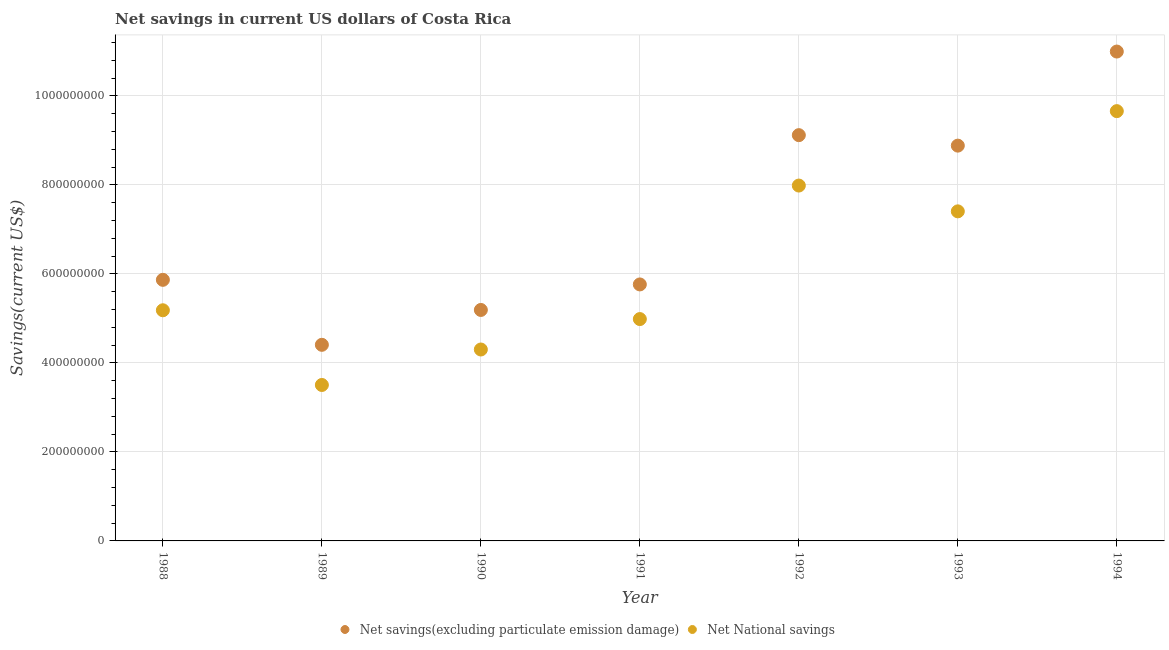What is the net savings(excluding particulate emission damage) in 1990?
Your answer should be very brief. 5.19e+08. Across all years, what is the maximum net savings(excluding particulate emission damage)?
Your answer should be compact. 1.10e+09. Across all years, what is the minimum net savings(excluding particulate emission damage)?
Give a very brief answer. 4.41e+08. In which year was the net national savings maximum?
Your answer should be compact. 1994. In which year was the net national savings minimum?
Your answer should be compact. 1989. What is the total net savings(excluding particulate emission damage) in the graph?
Your response must be concise. 5.02e+09. What is the difference between the net national savings in 1989 and that in 1994?
Provide a short and direct response. -6.15e+08. What is the difference between the net national savings in 1990 and the net savings(excluding particulate emission damage) in 1991?
Your answer should be very brief. -1.46e+08. What is the average net national savings per year?
Ensure brevity in your answer.  6.14e+08. In the year 1991, what is the difference between the net national savings and net savings(excluding particulate emission damage)?
Keep it short and to the point. -7.78e+07. In how many years, is the net national savings greater than 480000000 US$?
Provide a succinct answer. 5. What is the ratio of the net national savings in 1988 to that in 1991?
Make the answer very short. 1.04. Is the difference between the net national savings in 1990 and 1993 greater than the difference between the net savings(excluding particulate emission damage) in 1990 and 1993?
Your answer should be compact. Yes. What is the difference between the highest and the second highest net savings(excluding particulate emission damage)?
Your response must be concise. 1.88e+08. What is the difference between the highest and the lowest net savings(excluding particulate emission damage)?
Your response must be concise. 6.59e+08. In how many years, is the net national savings greater than the average net national savings taken over all years?
Provide a succinct answer. 3. Is the sum of the net savings(excluding particulate emission damage) in 1988 and 1989 greater than the maximum net national savings across all years?
Make the answer very short. Yes. Is the net savings(excluding particulate emission damage) strictly less than the net national savings over the years?
Provide a succinct answer. No. How many dotlines are there?
Your answer should be very brief. 2. How many years are there in the graph?
Ensure brevity in your answer.  7. What is the difference between two consecutive major ticks on the Y-axis?
Ensure brevity in your answer.  2.00e+08. Where does the legend appear in the graph?
Provide a succinct answer. Bottom center. How many legend labels are there?
Keep it short and to the point. 2. How are the legend labels stacked?
Your response must be concise. Horizontal. What is the title of the graph?
Your response must be concise. Net savings in current US dollars of Costa Rica. Does "Forest" appear as one of the legend labels in the graph?
Keep it short and to the point. No. What is the label or title of the Y-axis?
Offer a very short reply. Savings(current US$). What is the Savings(current US$) in Net savings(excluding particulate emission damage) in 1988?
Your answer should be compact. 5.87e+08. What is the Savings(current US$) of Net National savings in 1988?
Offer a terse response. 5.18e+08. What is the Savings(current US$) in Net savings(excluding particulate emission damage) in 1989?
Keep it short and to the point. 4.41e+08. What is the Savings(current US$) of Net National savings in 1989?
Provide a succinct answer. 3.50e+08. What is the Savings(current US$) in Net savings(excluding particulate emission damage) in 1990?
Offer a very short reply. 5.19e+08. What is the Savings(current US$) in Net National savings in 1990?
Your response must be concise. 4.30e+08. What is the Savings(current US$) in Net savings(excluding particulate emission damage) in 1991?
Your answer should be compact. 5.76e+08. What is the Savings(current US$) of Net National savings in 1991?
Your answer should be very brief. 4.98e+08. What is the Savings(current US$) of Net savings(excluding particulate emission damage) in 1992?
Keep it short and to the point. 9.12e+08. What is the Savings(current US$) of Net National savings in 1992?
Give a very brief answer. 7.98e+08. What is the Savings(current US$) in Net savings(excluding particulate emission damage) in 1993?
Give a very brief answer. 8.88e+08. What is the Savings(current US$) of Net National savings in 1993?
Provide a succinct answer. 7.40e+08. What is the Savings(current US$) of Net savings(excluding particulate emission damage) in 1994?
Your answer should be compact. 1.10e+09. What is the Savings(current US$) of Net National savings in 1994?
Give a very brief answer. 9.66e+08. Across all years, what is the maximum Savings(current US$) of Net savings(excluding particulate emission damage)?
Your answer should be compact. 1.10e+09. Across all years, what is the maximum Savings(current US$) in Net National savings?
Your answer should be very brief. 9.66e+08. Across all years, what is the minimum Savings(current US$) in Net savings(excluding particulate emission damage)?
Provide a short and direct response. 4.41e+08. Across all years, what is the minimum Savings(current US$) in Net National savings?
Your response must be concise. 3.50e+08. What is the total Savings(current US$) of Net savings(excluding particulate emission damage) in the graph?
Your answer should be compact. 5.02e+09. What is the total Savings(current US$) of Net National savings in the graph?
Your answer should be very brief. 4.30e+09. What is the difference between the Savings(current US$) in Net savings(excluding particulate emission damage) in 1988 and that in 1989?
Give a very brief answer. 1.46e+08. What is the difference between the Savings(current US$) of Net National savings in 1988 and that in 1989?
Provide a short and direct response. 1.68e+08. What is the difference between the Savings(current US$) in Net savings(excluding particulate emission damage) in 1988 and that in 1990?
Ensure brevity in your answer.  6.77e+07. What is the difference between the Savings(current US$) of Net National savings in 1988 and that in 1990?
Your answer should be compact. 8.81e+07. What is the difference between the Savings(current US$) of Net savings(excluding particulate emission damage) in 1988 and that in 1991?
Offer a very short reply. 1.03e+07. What is the difference between the Savings(current US$) of Net National savings in 1988 and that in 1991?
Provide a succinct answer. 1.98e+07. What is the difference between the Savings(current US$) in Net savings(excluding particulate emission damage) in 1988 and that in 1992?
Ensure brevity in your answer.  -3.25e+08. What is the difference between the Savings(current US$) of Net National savings in 1988 and that in 1992?
Make the answer very short. -2.80e+08. What is the difference between the Savings(current US$) of Net savings(excluding particulate emission damage) in 1988 and that in 1993?
Keep it short and to the point. -3.02e+08. What is the difference between the Savings(current US$) in Net National savings in 1988 and that in 1993?
Give a very brief answer. -2.22e+08. What is the difference between the Savings(current US$) in Net savings(excluding particulate emission damage) in 1988 and that in 1994?
Your answer should be very brief. -5.13e+08. What is the difference between the Savings(current US$) in Net National savings in 1988 and that in 1994?
Provide a succinct answer. -4.47e+08. What is the difference between the Savings(current US$) of Net savings(excluding particulate emission damage) in 1989 and that in 1990?
Your answer should be very brief. -7.83e+07. What is the difference between the Savings(current US$) in Net National savings in 1989 and that in 1990?
Make the answer very short. -7.97e+07. What is the difference between the Savings(current US$) in Net savings(excluding particulate emission damage) in 1989 and that in 1991?
Keep it short and to the point. -1.36e+08. What is the difference between the Savings(current US$) in Net National savings in 1989 and that in 1991?
Keep it short and to the point. -1.48e+08. What is the difference between the Savings(current US$) in Net savings(excluding particulate emission damage) in 1989 and that in 1992?
Your answer should be compact. -4.71e+08. What is the difference between the Savings(current US$) of Net National savings in 1989 and that in 1992?
Offer a very short reply. -4.48e+08. What is the difference between the Savings(current US$) in Net savings(excluding particulate emission damage) in 1989 and that in 1993?
Your answer should be compact. -4.47e+08. What is the difference between the Savings(current US$) of Net National savings in 1989 and that in 1993?
Your response must be concise. -3.90e+08. What is the difference between the Savings(current US$) in Net savings(excluding particulate emission damage) in 1989 and that in 1994?
Ensure brevity in your answer.  -6.59e+08. What is the difference between the Savings(current US$) in Net National savings in 1989 and that in 1994?
Provide a short and direct response. -6.15e+08. What is the difference between the Savings(current US$) in Net savings(excluding particulate emission damage) in 1990 and that in 1991?
Provide a short and direct response. -5.73e+07. What is the difference between the Savings(current US$) in Net National savings in 1990 and that in 1991?
Provide a succinct answer. -6.84e+07. What is the difference between the Savings(current US$) of Net savings(excluding particulate emission damage) in 1990 and that in 1992?
Offer a terse response. -3.93e+08. What is the difference between the Savings(current US$) of Net National savings in 1990 and that in 1992?
Provide a short and direct response. -3.68e+08. What is the difference between the Savings(current US$) of Net savings(excluding particulate emission damage) in 1990 and that in 1993?
Make the answer very short. -3.69e+08. What is the difference between the Savings(current US$) in Net National savings in 1990 and that in 1993?
Offer a terse response. -3.10e+08. What is the difference between the Savings(current US$) of Net savings(excluding particulate emission damage) in 1990 and that in 1994?
Offer a terse response. -5.81e+08. What is the difference between the Savings(current US$) in Net National savings in 1990 and that in 1994?
Your response must be concise. -5.36e+08. What is the difference between the Savings(current US$) of Net savings(excluding particulate emission damage) in 1991 and that in 1992?
Offer a very short reply. -3.35e+08. What is the difference between the Savings(current US$) of Net National savings in 1991 and that in 1992?
Ensure brevity in your answer.  -3.00e+08. What is the difference between the Savings(current US$) in Net savings(excluding particulate emission damage) in 1991 and that in 1993?
Provide a succinct answer. -3.12e+08. What is the difference between the Savings(current US$) of Net National savings in 1991 and that in 1993?
Provide a succinct answer. -2.42e+08. What is the difference between the Savings(current US$) in Net savings(excluding particulate emission damage) in 1991 and that in 1994?
Offer a very short reply. -5.23e+08. What is the difference between the Savings(current US$) in Net National savings in 1991 and that in 1994?
Make the answer very short. -4.67e+08. What is the difference between the Savings(current US$) of Net savings(excluding particulate emission damage) in 1992 and that in 1993?
Your response must be concise. 2.36e+07. What is the difference between the Savings(current US$) of Net National savings in 1992 and that in 1993?
Your answer should be very brief. 5.79e+07. What is the difference between the Savings(current US$) in Net savings(excluding particulate emission damage) in 1992 and that in 1994?
Provide a short and direct response. -1.88e+08. What is the difference between the Savings(current US$) of Net National savings in 1992 and that in 1994?
Provide a short and direct response. -1.67e+08. What is the difference between the Savings(current US$) in Net savings(excluding particulate emission damage) in 1993 and that in 1994?
Your answer should be very brief. -2.11e+08. What is the difference between the Savings(current US$) in Net National savings in 1993 and that in 1994?
Offer a terse response. -2.25e+08. What is the difference between the Savings(current US$) of Net savings(excluding particulate emission damage) in 1988 and the Savings(current US$) of Net National savings in 1989?
Your response must be concise. 2.36e+08. What is the difference between the Savings(current US$) of Net savings(excluding particulate emission damage) in 1988 and the Savings(current US$) of Net National savings in 1990?
Your answer should be very brief. 1.57e+08. What is the difference between the Savings(current US$) in Net savings(excluding particulate emission damage) in 1988 and the Savings(current US$) in Net National savings in 1991?
Provide a short and direct response. 8.81e+07. What is the difference between the Savings(current US$) of Net savings(excluding particulate emission damage) in 1988 and the Savings(current US$) of Net National savings in 1992?
Give a very brief answer. -2.12e+08. What is the difference between the Savings(current US$) of Net savings(excluding particulate emission damage) in 1988 and the Savings(current US$) of Net National savings in 1993?
Make the answer very short. -1.54e+08. What is the difference between the Savings(current US$) in Net savings(excluding particulate emission damage) in 1988 and the Savings(current US$) in Net National savings in 1994?
Your answer should be very brief. -3.79e+08. What is the difference between the Savings(current US$) in Net savings(excluding particulate emission damage) in 1989 and the Savings(current US$) in Net National savings in 1990?
Give a very brief answer. 1.05e+07. What is the difference between the Savings(current US$) of Net savings(excluding particulate emission damage) in 1989 and the Savings(current US$) of Net National savings in 1991?
Provide a short and direct response. -5.78e+07. What is the difference between the Savings(current US$) in Net savings(excluding particulate emission damage) in 1989 and the Savings(current US$) in Net National savings in 1992?
Make the answer very short. -3.58e+08. What is the difference between the Savings(current US$) of Net savings(excluding particulate emission damage) in 1989 and the Savings(current US$) of Net National savings in 1993?
Your response must be concise. -3.00e+08. What is the difference between the Savings(current US$) in Net savings(excluding particulate emission damage) in 1989 and the Savings(current US$) in Net National savings in 1994?
Ensure brevity in your answer.  -5.25e+08. What is the difference between the Savings(current US$) in Net savings(excluding particulate emission damage) in 1990 and the Savings(current US$) in Net National savings in 1991?
Provide a succinct answer. 2.05e+07. What is the difference between the Savings(current US$) in Net savings(excluding particulate emission damage) in 1990 and the Savings(current US$) in Net National savings in 1992?
Provide a short and direct response. -2.79e+08. What is the difference between the Savings(current US$) in Net savings(excluding particulate emission damage) in 1990 and the Savings(current US$) in Net National savings in 1993?
Give a very brief answer. -2.22e+08. What is the difference between the Savings(current US$) in Net savings(excluding particulate emission damage) in 1990 and the Savings(current US$) in Net National savings in 1994?
Offer a terse response. -4.47e+08. What is the difference between the Savings(current US$) of Net savings(excluding particulate emission damage) in 1991 and the Savings(current US$) of Net National savings in 1992?
Ensure brevity in your answer.  -2.22e+08. What is the difference between the Savings(current US$) in Net savings(excluding particulate emission damage) in 1991 and the Savings(current US$) in Net National savings in 1993?
Your answer should be very brief. -1.64e+08. What is the difference between the Savings(current US$) of Net savings(excluding particulate emission damage) in 1991 and the Savings(current US$) of Net National savings in 1994?
Keep it short and to the point. -3.89e+08. What is the difference between the Savings(current US$) of Net savings(excluding particulate emission damage) in 1992 and the Savings(current US$) of Net National savings in 1993?
Your answer should be very brief. 1.71e+08. What is the difference between the Savings(current US$) of Net savings(excluding particulate emission damage) in 1992 and the Savings(current US$) of Net National savings in 1994?
Give a very brief answer. -5.40e+07. What is the difference between the Savings(current US$) in Net savings(excluding particulate emission damage) in 1993 and the Savings(current US$) in Net National savings in 1994?
Offer a very short reply. -7.75e+07. What is the average Savings(current US$) of Net savings(excluding particulate emission damage) per year?
Ensure brevity in your answer.  7.17e+08. What is the average Savings(current US$) in Net National savings per year?
Provide a short and direct response. 6.14e+08. In the year 1988, what is the difference between the Savings(current US$) of Net savings(excluding particulate emission damage) and Savings(current US$) of Net National savings?
Keep it short and to the point. 6.84e+07. In the year 1989, what is the difference between the Savings(current US$) in Net savings(excluding particulate emission damage) and Savings(current US$) in Net National savings?
Make the answer very short. 9.02e+07. In the year 1990, what is the difference between the Savings(current US$) of Net savings(excluding particulate emission damage) and Savings(current US$) of Net National savings?
Keep it short and to the point. 8.89e+07. In the year 1991, what is the difference between the Savings(current US$) of Net savings(excluding particulate emission damage) and Savings(current US$) of Net National savings?
Provide a short and direct response. 7.78e+07. In the year 1992, what is the difference between the Savings(current US$) of Net savings(excluding particulate emission damage) and Savings(current US$) of Net National savings?
Offer a terse response. 1.13e+08. In the year 1993, what is the difference between the Savings(current US$) of Net savings(excluding particulate emission damage) and Savings(current US$) of Net National savings?
Provide a succinct answer. 1.48e+08. In the year 1994, what is the difference between the Savings(current US$) in Net savings(excluding particulate emission damage) and Savings(current US$) in Net National savings?
Offer a very short reply. 1.34e+08. What is the ratio of the Savings(current US$) in Net savings(excluding particulate emission damage) in 1988 to that in 1989?
Your answer should be compact. 1.33. What is the ratio of the Savings(current US$) of Net National savings in 1988 to that in 1989?
Offer a terse response. 1.48. What is the ratio of the Savings(current US$) in Net savings(excluding particulate emission damage) in 1988 to that in 1990?
Keep it short and to the point. 1.13. What is the ratio of the Savings(current US$) in Net National savings in 1988 to that in 1990?
Your response must be concise. 1.21. What is the ratio of the Savings(current US$) in Net savings(excluding particulate emission damage) in 1988 to that in 1991?
Provide a short and direct response. 1.02. What is the ratio of the Savings(current US$) in Net National savings in 1988 to that in 1991?
Provide a short and direct response. 1.04. What is the ratio of the Savings(current US$) of Net savings(excluding particulate emission damage) in 1988 to that in 1992?
Keep it short and to the point. 0.64. What is the ratio of the Savings(current US$) of Net National savings in 1988 to that in 1992?
Your answer should be very brief. 0.65. What is the ratio of the Savings(current US$) in Net savings(excluding particulate emission damage) in 1988 to that in 1993?
Keep it short and to the point. 0.66. What is the ratio of the Savings(current US$) in Net National savings in 1988 to that in 1993?
Make the answer very short. 0.7. What is the ratio of the Savings(current US$) in Net savings(excluding particulate emission damage) in 1988 to that in 1994?
Keep it short and to the point. 0.53. What is the ratio of the Savings(current US$) of Net National savings in 1988 to that in 1994?
Your response must be concise. 0.54. What is the ratio of the Savings(current US$) in Net savings(excluding particulate emission damage) in 1989 to that in 1990?
Your response must be concise. 0.85. What is the ratio of the Savings(current US$) in Net National savings in 1989 to that in 1990?
Ensure brevity in your answer.  0.81. What is the ratio of the Savings(current US$) of Net savings(excluding particulate emission damage) in 1989 to that in 1991?
Provide a succinct answer. 0.76. What is the ratio of the Savings(current US$) of Net National savings in 1989 to that in 1991?
Ensure brevity in your answer.  0.7. What is the ratio of the Savings(current US$) in Net savings(excluding particulate emission damage) in 1989 to that in 1992?
Offer a terse response. 0.48. What is the ratio of the Savings(current US$) of Net National savings in 1989 to that in 1992?
Provide a succinct answer. 0.44. What is the ratio of the Savings(current US$) in Net savings(excluding particulate emission damage) in 1989 to that in 1993?
Your response must be concise. 0.5. What is the ratio of the Savings(current US$) of Net National savings in 1989 to that in 1993?
Give a very brief answer. 0.47. What is the ratio of the Savings(current US$) in Net savings(excluding particulate emission damage) in 1989 to that in 1994?
Your answer should be compact. 0.4. What is the ratio of the Savings(current US$) of Net National savings in 1989 to that in 1994?
Offer a terse response. 0.36. What is the ratio of the Savings(current US$) of Net savings(excluding particulate emission damage) in 1990 to that in 1991?
Ensure brevity in your answer.  0.9. What is the ratio of the Savings(current US$) in Net National savings in 1990 to that in 1991?
Offer a very short reply. 0.86. What is the ratio of the Savings(current US$) in Net savings(excluding particulate emission damage) in 1990 to that in 1992?
Your answer should be compact. 0.57. What is the ratio of the Savings(current US$) in Net National savings in 1990 to that in 1992?
Your response must be concise. 0.54. What is the ratio of the Savings(current US$) of Net savings(excluding particulate emission damage) in 1990 to that in 1993?
Give a very brief answer. 0.58. What is the ratio of the Savings(current US$) of Net National savings in 1990 to that in 1993?
Provide a short and direct response. 0.58. What is the ratio of the Savings(current US$) of Net savings(excluding particulate emission damage) in 1990 to that in 1994?
Your response must be concise. 0.47. What is the ratio of the Savings(current US$) of Net National savings in 1990 to that in 1994?
Provide a short and direct response. 0.45. What is the ratio of the Savings(current US$) of Net savings(excluding particulate emission damage) in 1991 to that in 1992?
Provide a short and direct response. 0.63. What is the ratio of the Savings(current US$) in Net National savings in 1991 to that in 1992?
Make the answer very short. 0.62. What is the ratio of the Savings(current US$) of Net savings(excluding particulate emission damage) in 1991 to that in 1993?
Keep it short and to the point. 0.65. What is the ratio of the Savings(current US$) in Net National savings in 1991 to that in 1993?
Offer a very short reply. 0.67. What is the ratio of the Savings(current US$) in Net savings(excluding particulate emission damage) in 1991 to that in 1994?
Provide a succinct answer. 0.52. What is the ratio of the Savings(current US$) of Net National savings in 1991 to that in 1994?
Offer a terse response. 0.52. What is the ratio of the Savings(current US$) of Net savings(excluding particulate emission damage) in 1992 to that in 1993?
Offer a very short reply. 1.03. What is the ratio of the Savings(current US$) in Net National savings in 1992 to that in 1993?
Your response must be concise. 1.08. What is the ratio of the Savings(current US$) of Net savings(excluding particulate emission damage) in 1992 to that in 1994?
Your answer should be very brief. 0.83. What is the ratio of the Savings(current US$) in Net National savings in 1992 to that in 1994?
Your answer should be very brief. 0.83. What is the ratio of the Savings(current US$) of Net savings(excluding particulate emission damage) in 1993 to that in 1994?
Keep it short and to the point. 0.81. What is the ratio of the Savings(current US$) in Net National savings in 1993 to that in 1994?
Provide a short and direct response. 0.77. What is the difference between the highest and the second highest Savings(current US$) of Net savings(excluding particulate emission damage)?
Your response must be concise. 1.88e+08. What is the difference between the highest and the second highest Savings(current US$) in Net National savings?
Give a very brief answer. 1.67e+08. What is the difference between the highest and the lowest Savings(current US$) in Net savings(excluding particulate emission damage)?
Ensure brevity in your answer.  6.59e+08. What is the difference between the highest and the lowest Savings(current US$) of Net National savings?
Provide a short and direct response. 6.15e+08. 